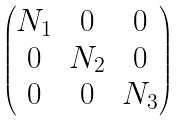<formula> <loc_0><loc_0><loc_500><loc_500>\begin{pmatrix} N _ { 1 } & 0 & 0 \\ 0 & N _ { 2 } & 0 \\ 0 & 0 & N _ { 3 } \end{pmatrix}</formula> 